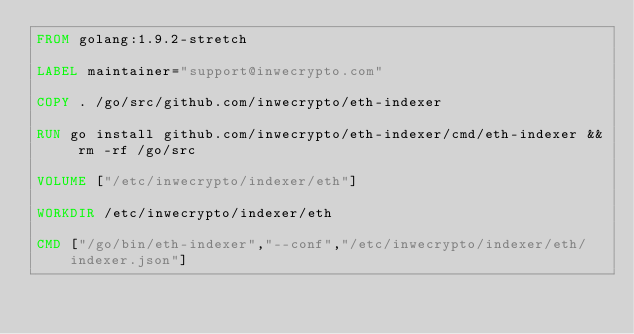Convert code to text. <code><loc_0><loc_0><loc_500><loc_500><_Dockerfile_>FROM golang:1.9.2-stretch

LABEL maintainer="support@inwecrypto.com"

COPY . /go/src/github.com/inwecrypto/eth-indexer

RUN go install github.com/inwecrypto/eth-indexer/cmd/eth-indexer && rm -rf /go/src

VOLUME ["/etc/inwecrypto/indexer/eth"]

WORKDIR /etc/inwecrypto/indexer/eth

CMD ["/go/bin/eth-indexer","--conf","/etc/inwecrypto/indexer/eth/indexer.json"]</code> 